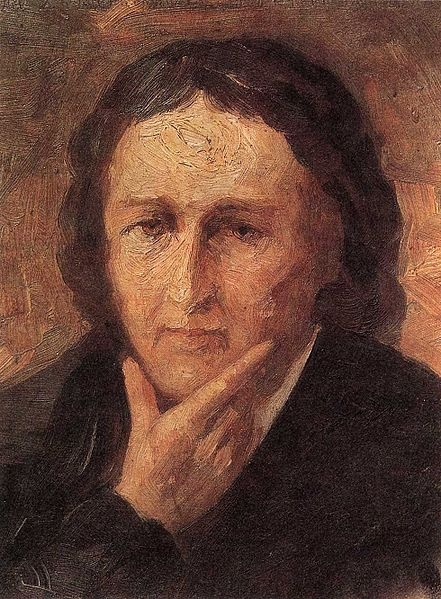Envision a futuristic scenario where this portrait is part of a digital art gallery. How might viewers interact with it using advanced technology? In a futuristic digital art gallery, viewers might interact with this portrait using augmented reality (AR) and virtual reality (VR) technology. By donning VR headsets or using AR apps on their devices, they could experience an immersive environment where the portrait comes to life. They might engage in a simulated conversation with the depicted person, exploring their thoughts and emotions. Furthermore, AI-driven art analysis tools could provide detailed insights into the artistic techniques, historical context, and emotional undertones, creating an enriching, interactive experience that bridges art and technology. 